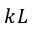<formula> <loc_0><loc_0><loc_500><loc_500>k L</formula> 